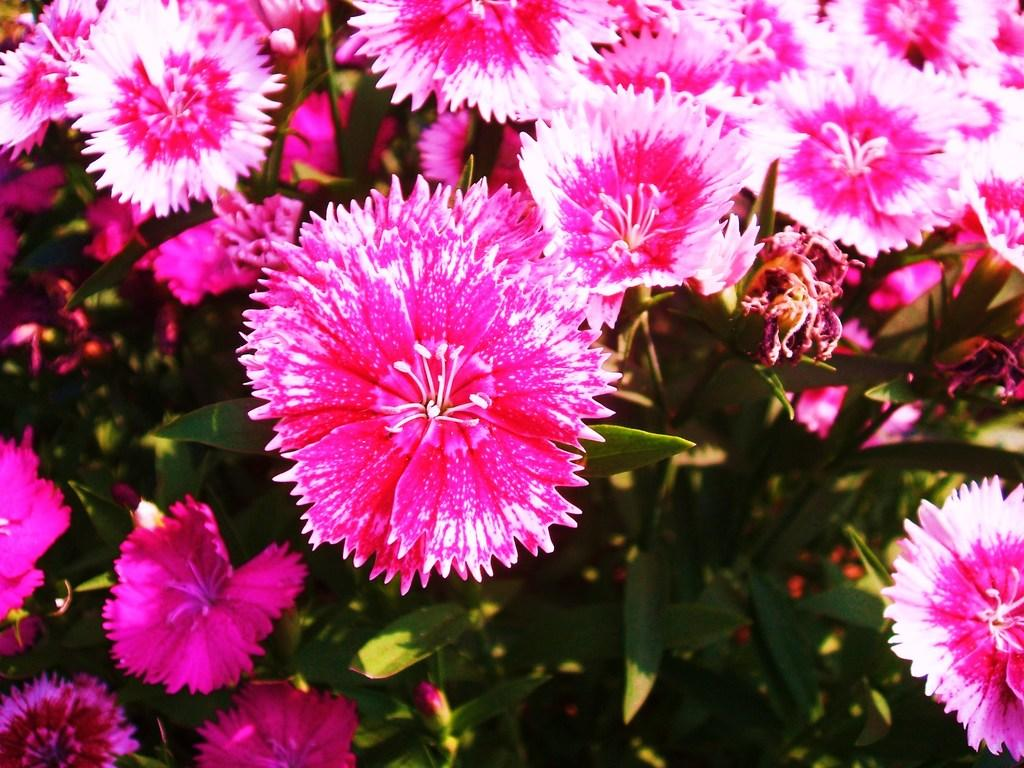What type of living organisms are present in the image? There are plants in the image. What specific features can be observed on the plants? The plants have flowers. What colors are the flowers? The flowers are of white and pink color. What type of drink is being served in the image? There is no drink present in the image; it features plants with white and pink flowers. How does the memory of the flowers affect the image? The image does not depict a memory or any emotional response to the flowers; it simply shows plants with flowers. 